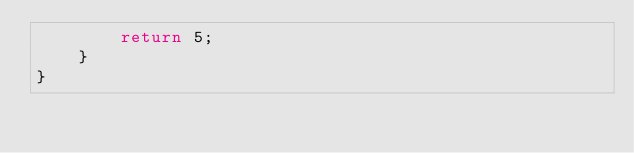Convert code to text. <code><loc_0><loc_0><loc_500><loc_500><_Java_>		return 5;
	}
}
</code> 